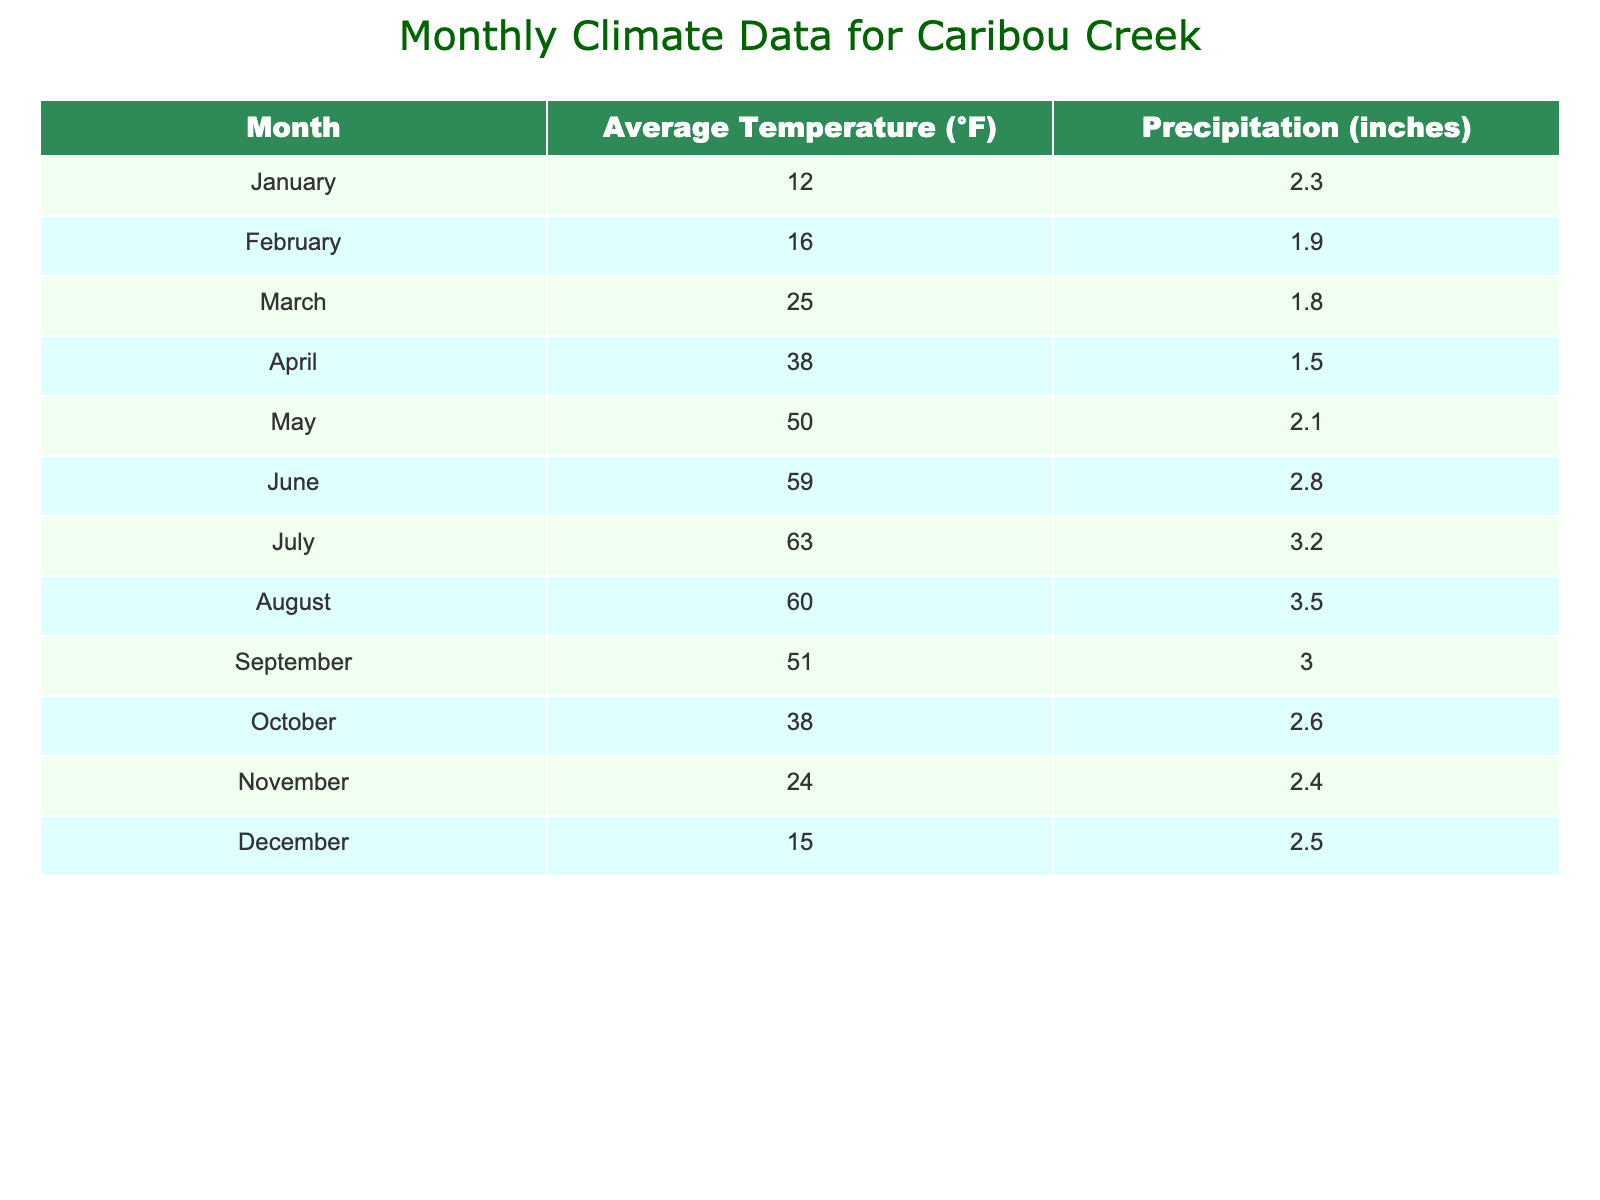What is the average temperature in July? The table lists the average temperature for each month, and for July, the value is directly provided as 63°F.
Answer: 63°F What is the total precipitation in the winter months (December, January, February)? The winter months are December (2.5 inches), January (2.3 inches), and February (1.9 inches). Adding these values gives 2.5 + 2.3 + 1.9 = 6.7 inches.
Answer: 6.7 inches Is the average temperature in March higher than in January? The average temperature in March is 25°F and in January it is 12°F. Since 25°F is greater than 12°F, the statement is true.
Answer: Yes What month has the highest average temperature, and what is that temperature? Examining the temperatures across the months, July shows the highest value at 63°F.
Answer: July, 63°F What is the average precipitation from April to September? First, find the precipitation for April (1.5), May (2.1), June (2.8), July (3.2), August (3.5), and September (3.0). Summing these gives 1.5 + 2.1 + 2.8 + 3.2 + 3.5 + 3.0 = 16.1 inches. Then, divide by the number of months (6) to find the average: 16.1 / 6 ≈ 2.68 inches.
Answer: 2.68 inches What is the difference in average temperature between the hottest month and the coldest month? The hottest month is July at 63°F and the coldest month is January at 12°F. The difference is calculated as 63 - 12 = 51°F.
Answer: 51°F Is there a month with less than 2 inches of precipitation? By reviewing the monthly precipitation values, April (1.5 inches) is the only month with less than 2 inches of precipitation. Therefore, the answer is yes.
Answer: Yes Which month has the highest precipitation, and how much is it? The table shows August has the highest precipitation at 3.5 inches.
Answer: August, 3.5 inches Calculate the average temperature for the entire year. The average temperatures for each month are: 12, 16, 25, 38, 50, 59, 63, 60, 51, 38, 24, and 15. Summing these gives 12 + 16 + 25 + 38 + 50 + 59 + 63 + 60 + 51 + 38 + 24 + 15 =  427. Dividing by 12 (the number of months) gives an average of 427 / 12 ≈ 35.58°F.
Answer: 35.58°F What is the precipitation in October, and is it higher than in March? The precipitation in October is 2.6 inches, while in March it is 1.8 inches. Since 2.6 inches is greater than 1.8 inches, the answer is yes.
Answer: Yes 